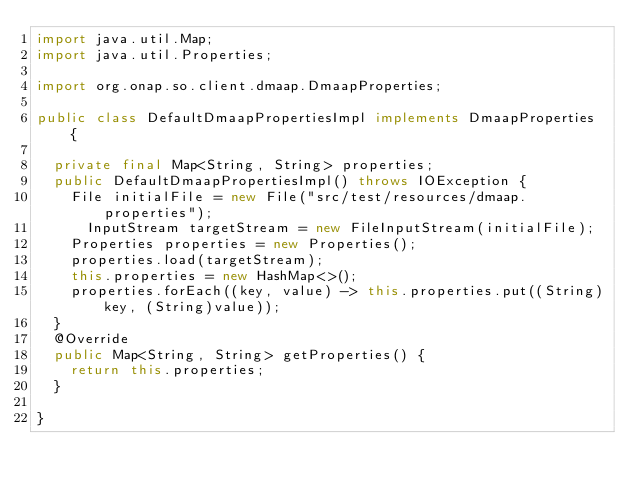Convert code to text. <code><loc_0><loc_0><loc_500><loc_500><_Java_>import java.util.Map;
import java.util.Properties;

import org.onap.so.client.dmaap.DmaapProperties;

public class DefaultDmaapPropertiesImpl implements DmaapProperties {

	private final Map<String, String> properties;
	public DefaultDmaapPropertiesImpl() throws IOException {
		File initialFile = new File("src/test/resources/dmaap.properties");
	    InputStream targetStream = new FileInputStream(initialFile);
		Properties properties = new Properties();
		properties.load(targetStream);
		this.properties = new HashMap<>();
		properties.forEach((key, value) -> this.properties.put((String)key, (String)value));
	}
	@Override
	public Map<String, String> getProperties() {
		return this.properties;
	} 

}
</code> 